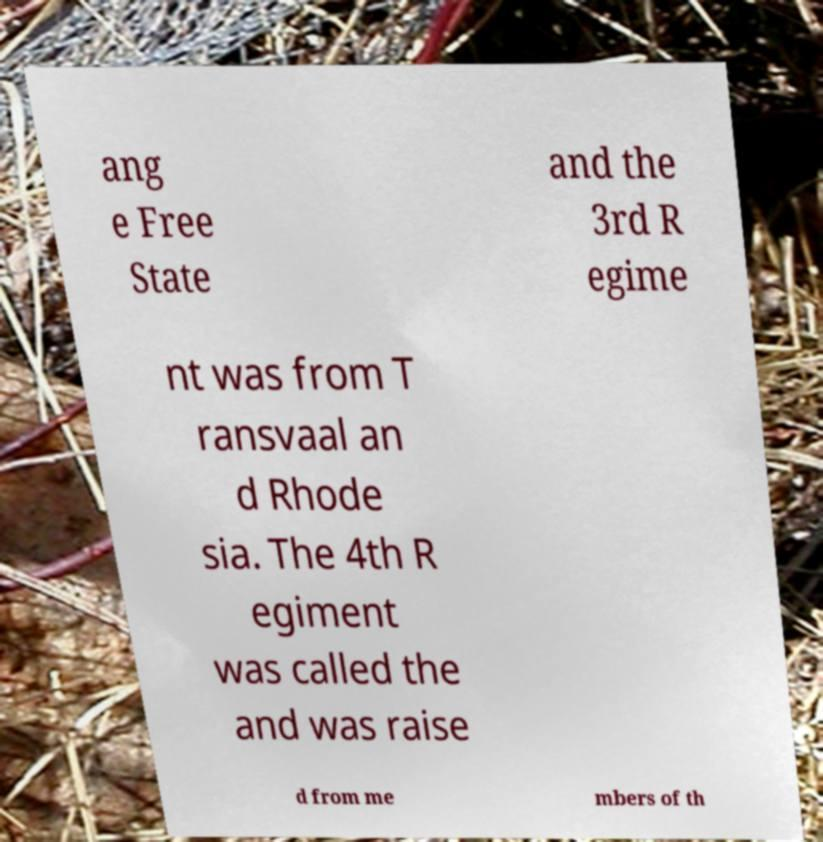Could you assist in decoding the text presented in this image and type it out clearly? ang e Free State and the 3rd R egime nt was from T ransvaal an d Rhode sia. The 4th R egiment was called the and was raise d from me mbers of th 